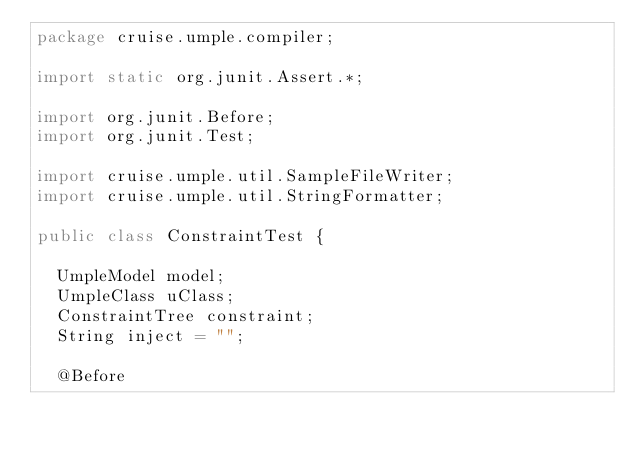Convert code to text. <code><loc_0><loc_0><loc_500><loc_500><_Java_>package cruise.umple.compiler;

import static org.junit.Assert.*;

import org.junit.Before;
import org.junit.Test;

import cruise.umple.util.SampleFileWriter;
import cruise.umple.util.StringFormatter;

public class ConstraintTest {

	UmpleModel model;
	UmpleClass uClass;
	ConstraintTree constraint;
	String inject = "";

	@Before</code> 